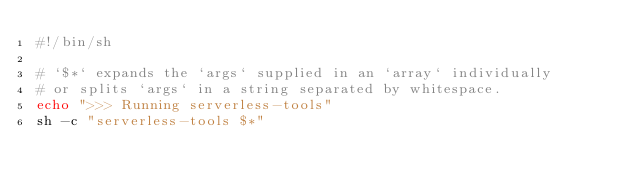Convert code to text. <code><loc_0><loc_0><loc_500><loc_500><_Bash_>#!/bin/sh

# `$*` expands the `args` supplied in an `array` individually
# or splits `args` in a string separated by whitespace.
echo ">>> Running serverless-tools"
sh -c "serverless-tools $*"
</code> 